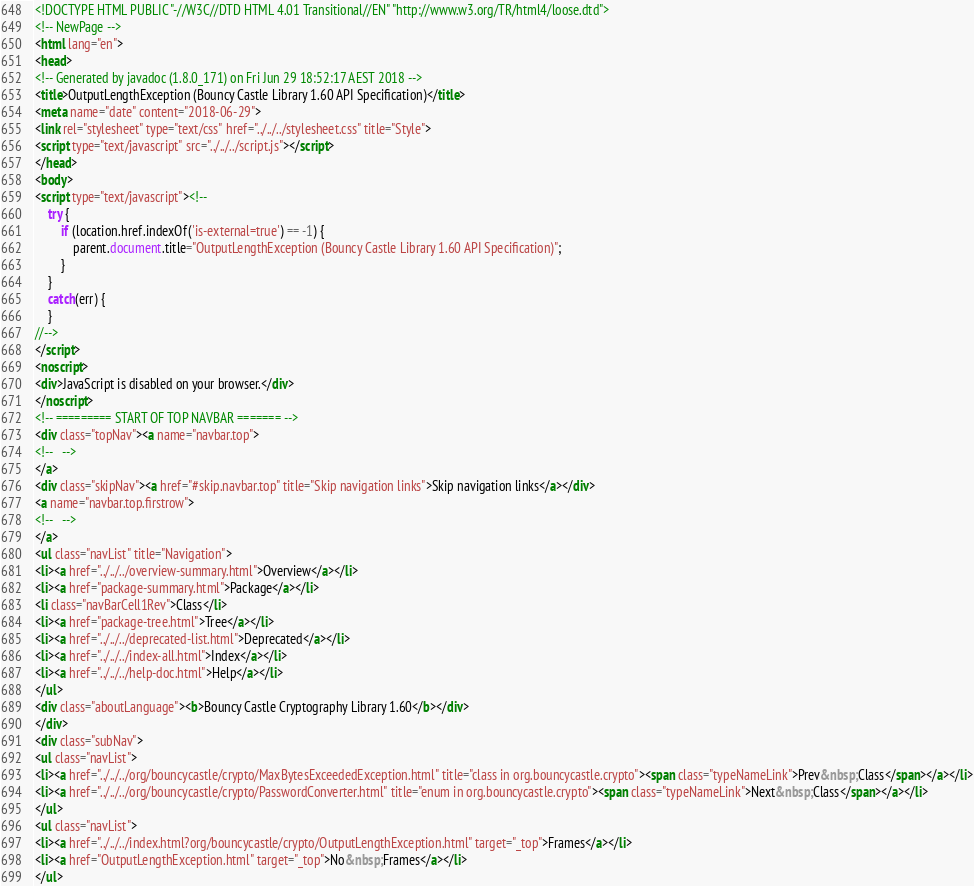Convert code to text. <code><loc_0><loc_0><loc_500><loc_500><_HTML_><!DOCTYPE HTML PUBLIC "-//W3C//DTD HTML 4.01 Transitional//EN" "http://www.w3.org/TR/html4/loose.dtd">
<!-- NewPage -->
<html lang="en">
<head>
<!-- Generated by javadoc (1.8.0_171) on Fri Jun 29 18:52:17 AEST 2018 -->
<title>OutputLengthException (Bouncy Castle Library 1.60 API Specification)</title>
<meta name="date" content="2018-06-29">
<link rel="stylesheet" type="text/css" href="../../../stylesheet.css" title="Style">
<script type="text/javascript" src="../../../script.js"></script>
</head>
<body>
<script type="text/javascript"><!--
    try {
        if (location.href.indexOf('is-external=true') == -1) {
            parent.document.title="OutputLengthException (Bouncy Castle Library 1.60 API Specification)";
        }
    }
    catch(err) {
    }
//-->
</script>
<noscript>
<div>JavaScript is disabled on your browser.</div>
</noscript>
<!-- ========= START OF TOP NAVBAR ======= -->
<div class="topNav"><a name="navbar.top">
<!--   -->
</a>
<div class="skipNav"><a href="#skip.navbar.top" title="Skip navigation links">Skip navigation links</a></div>
<a name="navbar.top.firstrow">
<!--   -->
</a>
<ul class="navList" title="Navigation">
<li><a href="../../../overview-summary.html">Overview</a></li>
<li><a href="package-summary.html">Package</a></li>
<li class="navBarCell1Rev">Class</li>
<li><a href="package-tree.html">Tree</a></li>
<li><a href="../../../deprecated-list.html">Deprecated</a></li>
<li><a href="../../../index-all.html">Index</a></li>
<li><a href="../../../help-doc.html">Help</a></li>
</ul>
<div class="aboutLanguage"><b>Bouncy Castle Cryptography Library 1.60</b></div>
</div>
<div class="subNav">
<ul class="navList">
<li><a href="../../../org/bouncycastle/crypto/MaxBytesExceededException.html" title="class in org.bouncycastle.crypto"><span class="typeNameLink">Prev&nbsp;Class</span></a></li>
<li><a href="../../../org/bouncycastle/crypto/PasswordConverter.html" title="enum in org.bouncycastle.crypto"><span class="typeNameLink">Next&nbsp;Class</span></a></li>
</ul>
<ul class="navList">
<li><a href="../../../index.html?org/bouncycastle/crypto/OutputLengthException.html" target="_top">Frames</a></li>
<li><a href="OutputLengthException.html" target="_top">No&nbsp;Frames</a></li>
</ul></code> 